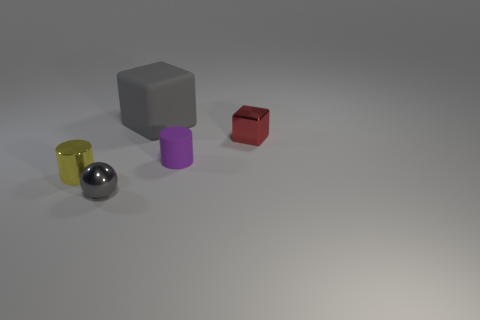Add 4 large red balls. How many objects exist? 9 Subtract 2 cylinders. How many cylinders are left? 0 Subtract all balls. How many objects are left? 4 Subtract all purple blocks. Subtract all green spheres. How many blocks are left? 2 Subtract all red cubes. How many yellow cylinders are left? 1 Subtract all tiny green metal cylinders. Subtract all tiny red metallic blocks. How many objects are left? 4 Add 3 small yellow metallic cylinders. How many small yellow metallic cylinders are left? 4 Add 4 big yellow cubes. How many big yellow cubes exist? 4 Subtract 0 purple cubes. How many objects are left? 5 